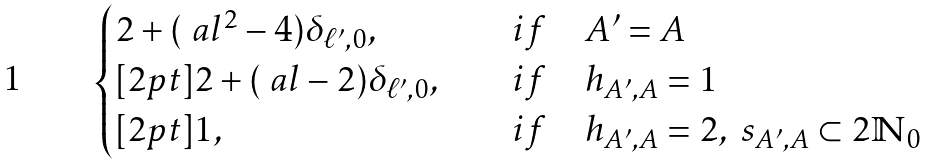Convert formula to latex. <formula><loc_0><loc_0><loc_500><loc_500>\begin{cases} 2 + ( \ a l ^ { 2 } - 4 ) \delta _ { \ell ^ { \prime } , 0 } , \quad & i f \quad A ^ { \prime } = A \\ [ 2 p t ] 2 + ( \ a l - 2 ) \delta _ { \ell ^ { \prime } , 0 } , \quad & i f \quad h _ { A ^ { \prime } , A } = 1 \\ [ 2 p t ] 1 , \quad & i f \quad h _ { A ^ { \prime } , A } = 2 , \ s _ { A ^ { \prime } , A } \subset 2 \mathbb { N } _ { 0 } \end{cases}</formula> 